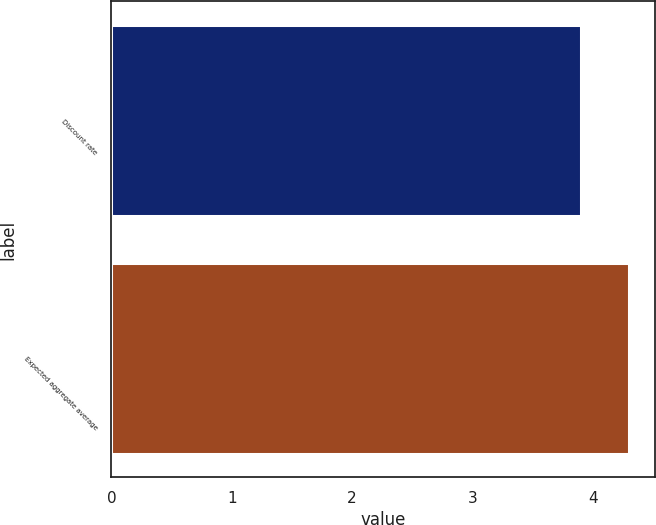<chart> <loc_0><loc_0><loc_500><loc_500><bar_chart><fcel>Discount rate<fcel>Expected aggregate average<nl><fcel>3.9<fcel>4.3<nl></chart> 